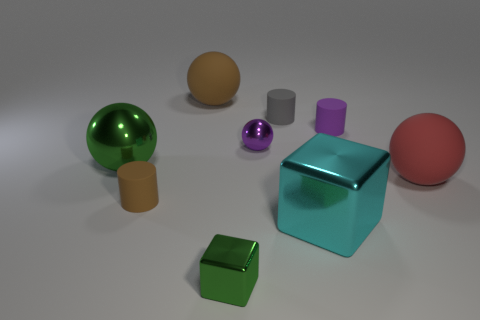Is the color of the tiny shiny cube the same as the large metal thing behind the red ball?
Offer a very short reply. Yes. How many purple things have the same shape as the cyan metal thing?
Your answer should be very brief. 0. There is a large metallic thing that is in front of the small rubber cylinder on the left side of the tiny gray object; what color is it?
Give a very brief answer. Cyan. Is the number of green metallic cubes in front of the tiny brown object the same as the number of yellow shiny cylinders?
Provide a succinct answer. No. Are there any purple matte things of the same size as the green ball?
Your response must be concise. No. There is a red rubber sphere; is it the same size as the metallic cube on the right side of the tiny purple metallic ball?
Make the answer very short. Yes. Are there an equal number of green things that are on the right side of the purple matte thing and cyan blocks on the right side of the large cube?
Provide a short and direct response. Yes. There is a matte object that is the same color as the tiny ball; what shape is it?
Provide a succinct answer. Cylinder. There is a brown thing in front of the brown sphere; what is its material?
Give a very brief answer. Rubber. Is the size of the purple metallic ball the same as the green shiny sphere?
Offer a terse response. No. 